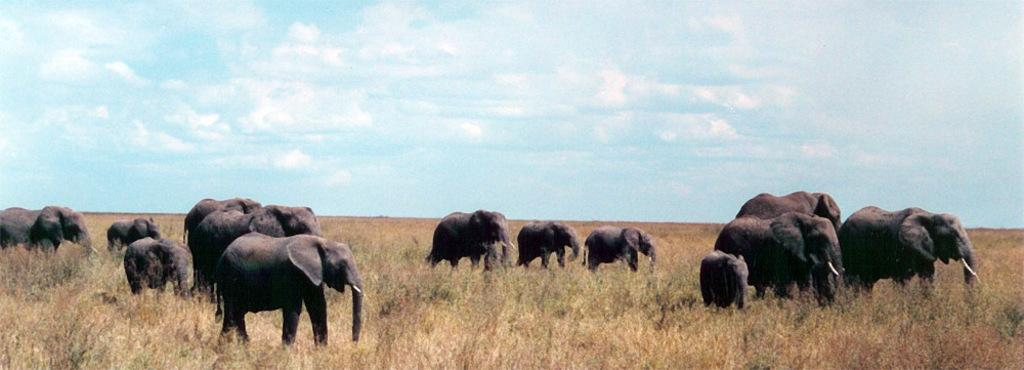What animals are present in the image? There is a herd of elephants in the picture. What type of vegetation can be seen in the image? There is grass visible in the picture. What can be seen in the background of the image? The sky is visible in the background of the picture. What type of cord is being used by the elephants in the image? There is no cord present in the image; it features a herd of elephants in a natural setting. 